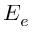Convert formula to latex. <formula><loc_0><loc_0><loc_500><loc_500>E _ { e }</formula> 